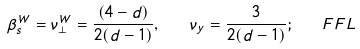Convert formula to latex. <formula><loc_0><loc_0><loc_500><loc_500>\beta _ { s } ^ { W } = \nu _ { \perp } ^ { W } = \frac { ( 4 - d ) } { 2 ( d - 1 ) } , \quad \nu _ { y } = \frac { 3 } { 2 ( d - 1 ) } ; \quad F F L</formula> 